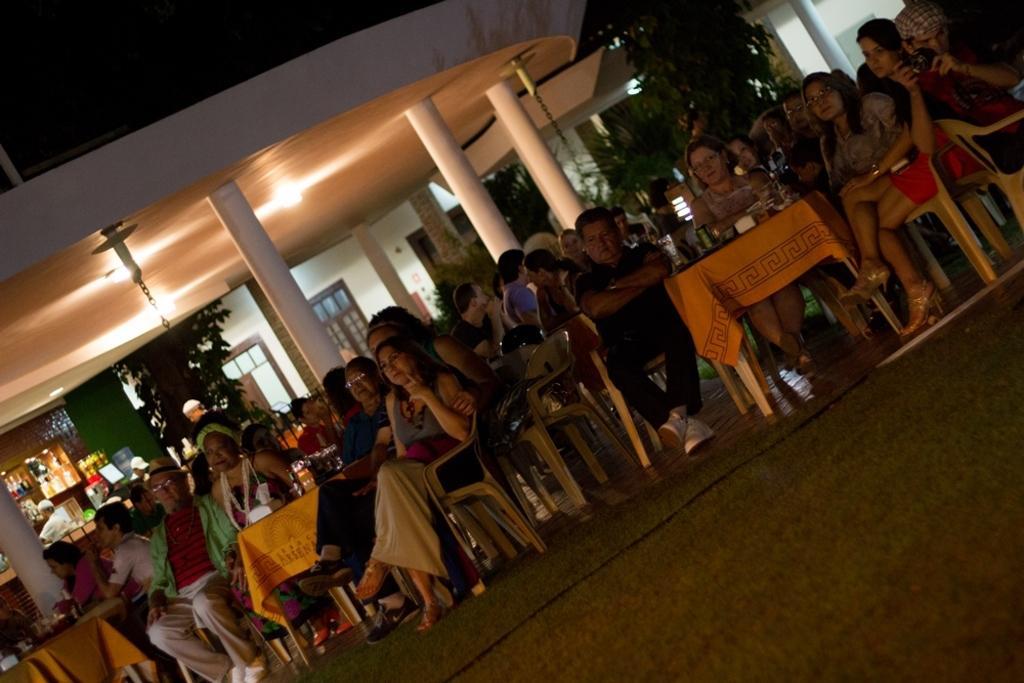Describe this image in one or two sentences. In this picture we can see a group of people sitting on chair and in front of them there is table and on table we have cloth, tins and background we can see pillars, tree, wall, window, racks and bottles in it. 